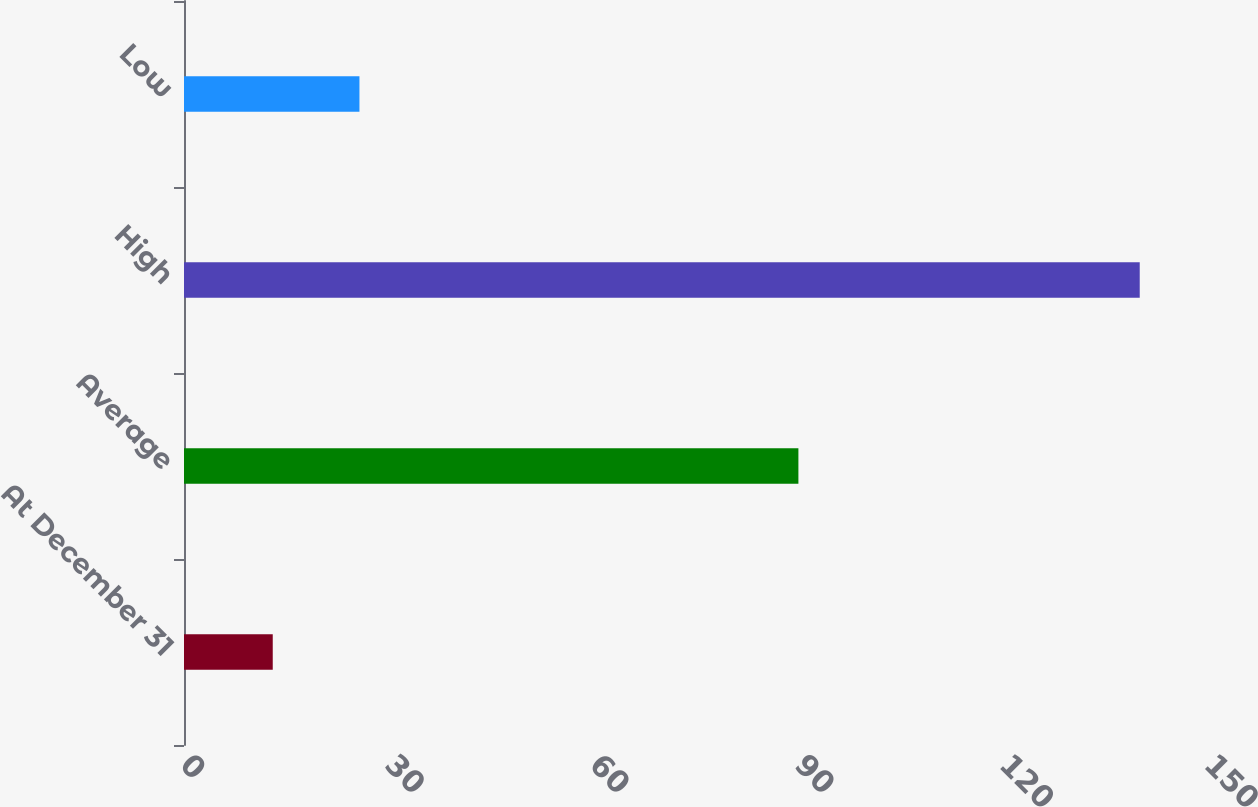Convert chart. <chart><loc_0><loc_0><loc_500><loc_500><bar_chart><fcel>At December 31<fcel>Average<fcel>High<fcel>Low<nl><fcel>13<fcel>90<fcel>140<fcel>25.7<nl></chart> 